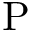<formula> <loc_0><loc_0><loc_500><loc_500>P</formula> 